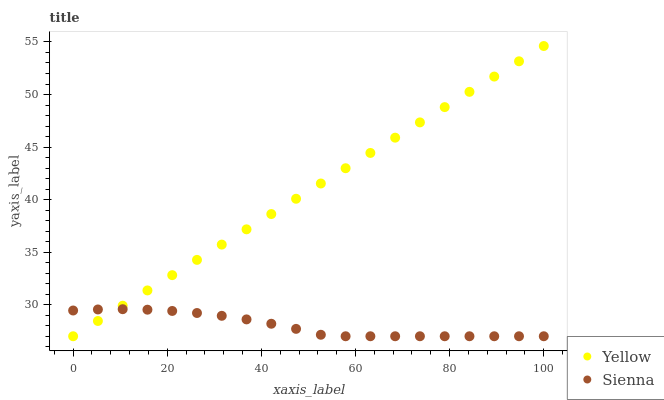Does Sienna have the minimum area under the curve?
Answer yes or no. Yes. Does Yellow have the maximum area under the curve?
Answer yes or no. Yes. Does Yellow have the minimum area under the curve?
Answer yes or no. No. Is Yellow the smoothest?
Answer yes or no. Yes. Is Sienna the roughest?
Answer yes or no. Yes. Is Yellow the roughest?
Answer yes or no. No. Does Sienna have the lowest value?
Answer yes or no. Yes. Does Yellow have the highest value?
Answer yes or no. Yes. Does Yellow intersect Sienna?
Answer yes or no. Yes. Is Yellow less than Sienna?
Answer yes or no. No. Is Yellow greater than Sienna?
Answer yes or no. No. 